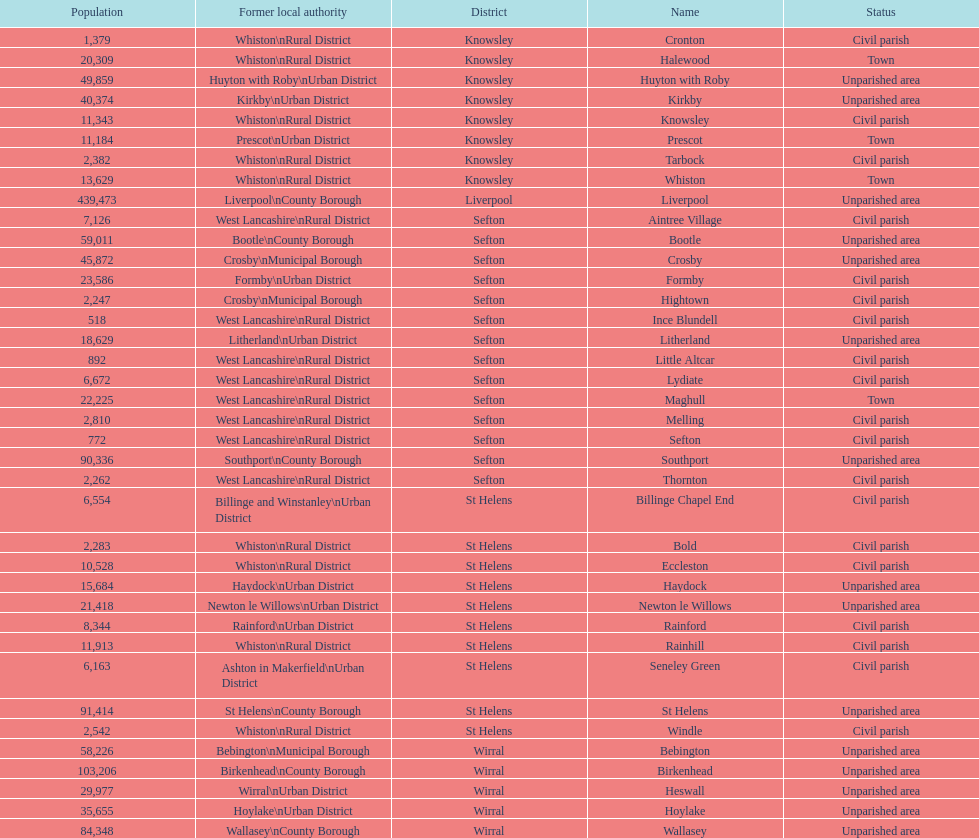Which is a civil parish, aintree village or maghull? Aintree Village. 